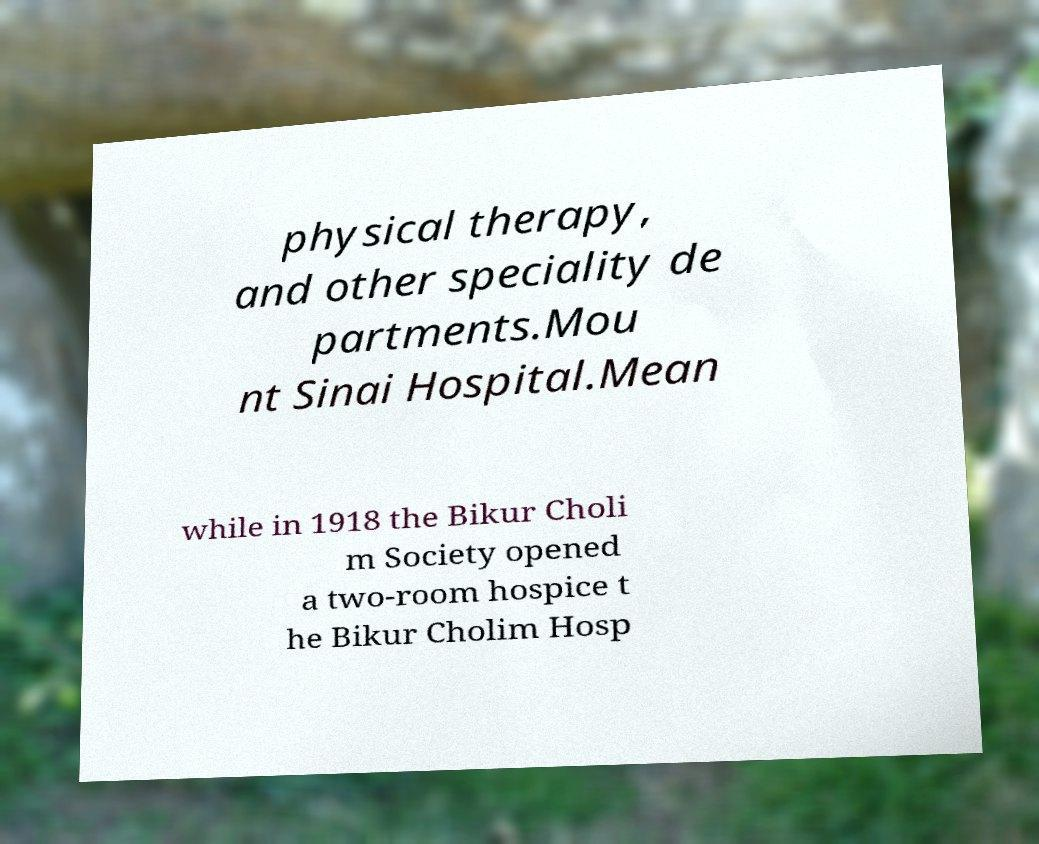Please read and relay the text visible in this image. What does it say? physical therapy, and other speciality de partments.Mou nt Sinai Hospital.Mean while in 1918 the Bikur Choli m Society opened a two-room hospice t he Bikur Cholim Hosp 